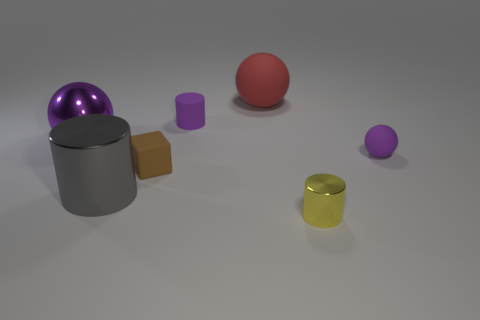Is the number of yellow matte objects less than the number of brown matte blocks?
Provide a succinct answer. Yes. There is a small purple matte cylinder that is right of the big metallic thing that is on the right side of the metal ball; is there a purple cylinder behind it?
Make the answer very short. No. What number of metal objects are either small green blocks or large red spheres?
Your answer should be very brief. 0. Does the tiny sphere have the same color as the metal sphere?
Ensure brevity in your answer.  Yes. There is a small brown cube; how many tiny objects are behind it?
Your response must be concise. 2. What number of objects are on the right side of the tiny yellow thing and left of the small brown thing?
Make the answer very short. 0. The tiny brown object that is made of the same material as the large red sphere is what shape?
Make the answer very short. Cube. There is a purple ball that is right of the big gray object; is its size the same as the gray thing in front of the big red rubber object?
Give a very brief answer. No. There is a tiny cylinder that is left of the yellow cylinder; what color is it?
Provide a short and direct response. Purple. The purple sphere that is behind the purple rubber object that is on the right side of the yellow cylinder is made of what material?
Make the answer very short. Metal. 